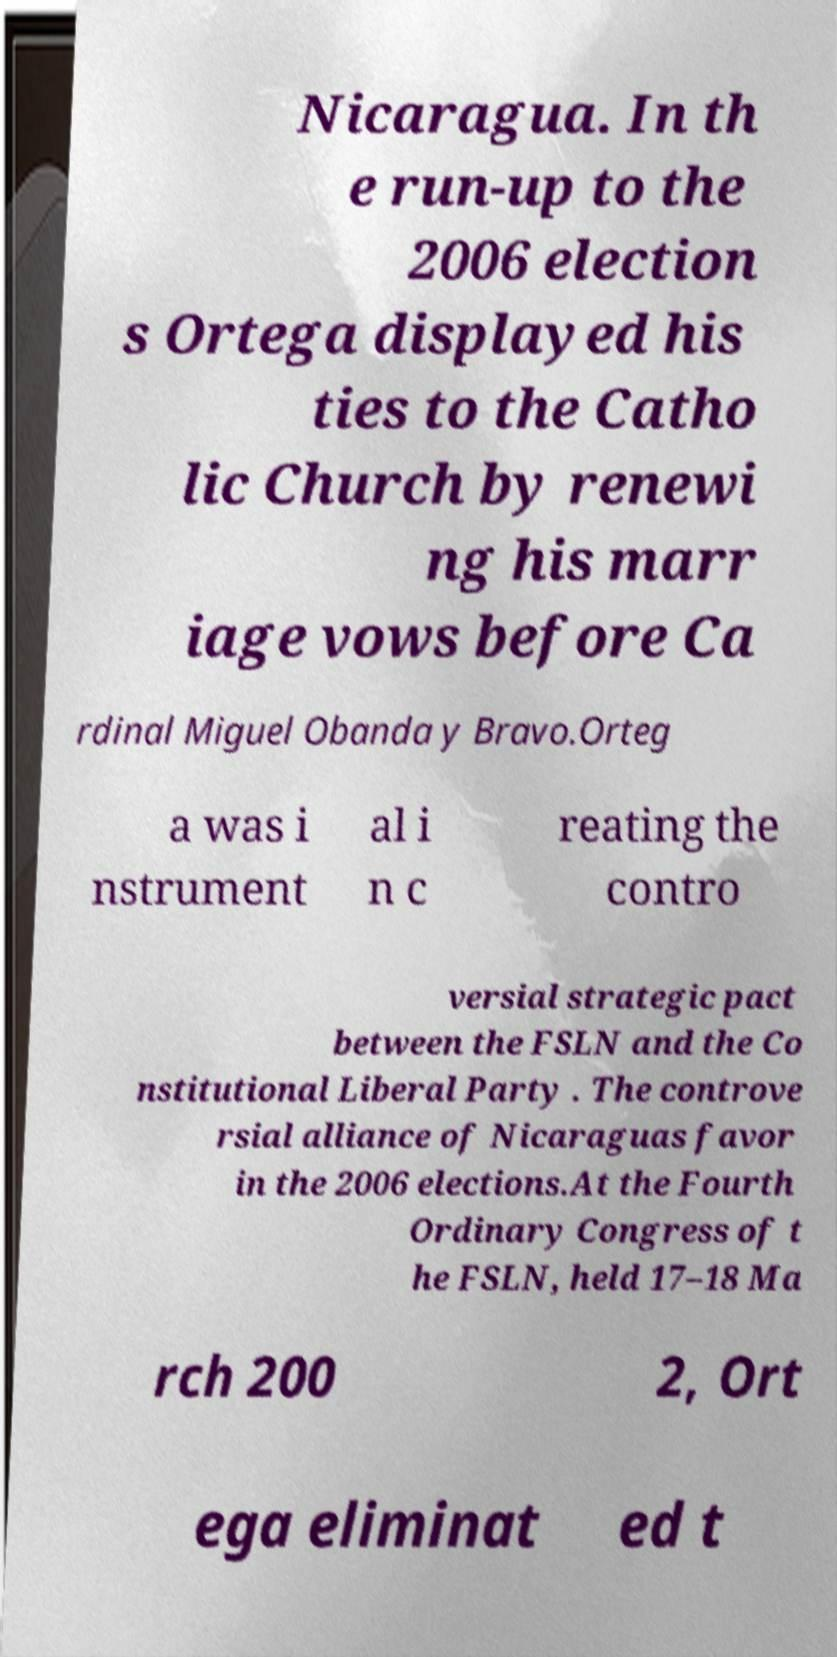Could you extract and type out the text from this image? Nicaragua. In th e run-up to the 2006 election s Ortega displayed his ties to the Catho lic Church by renewi ng his marr iage vows before Ca rdinal Miguel Obanda y Bravo.Orteg a was i nstrument al i n c reating the contro versial strategic pact between the FSLN and the Co nstitutional Liberal Party . The controve rsial alliance of Nicaraguas favor in the 2006 elections.At the Fourth Ordinary Congress of t he FSLN, held 17–18 Ma rch 200 2, Ort ega eliminat ed t 